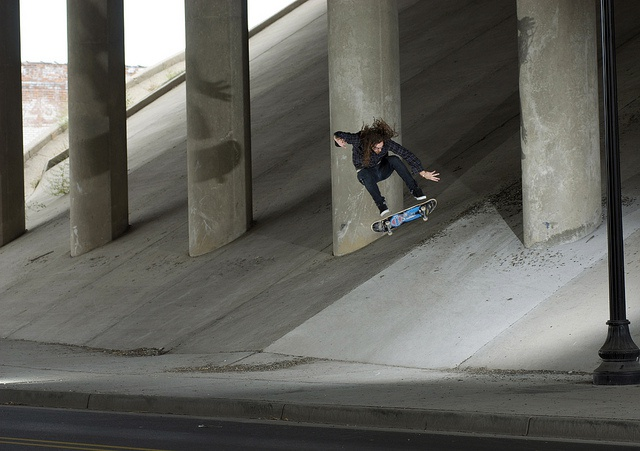Describe the objects in this image and their specific colors. I can see people in black, gray, and darkgray tones and skateboard in black, gray, and darkgray tones in this image. 